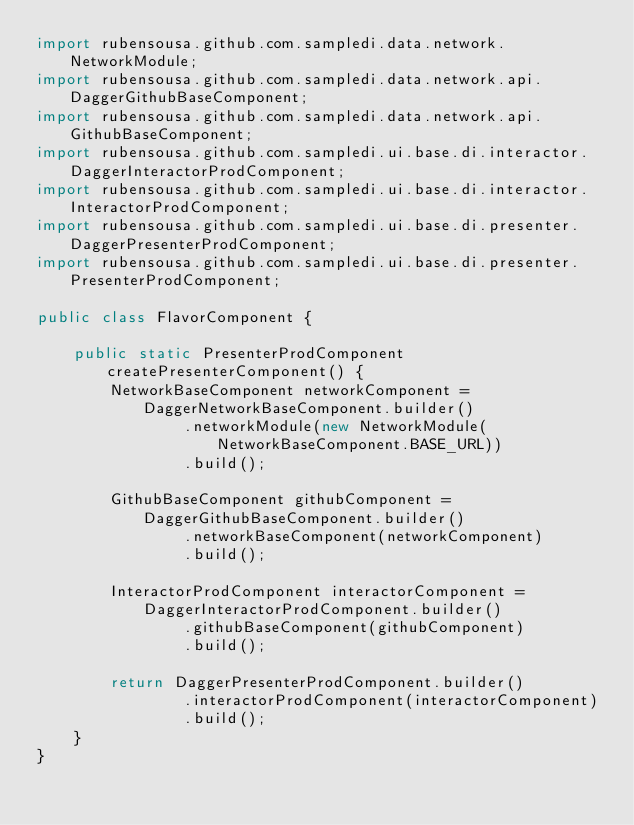<code> <loc_0><loc_0><loc_500><loc_500><_Java_>import rubensousa.github.com.sampledi.data.network.NetworkModule;
import rubensousa.github.com.sampledi.data.network.api.DaggerGithubBaseComponent;
import rubensousa.github.com.sampledi.data.network.api.GithubBaseComponent;
import rubensousa.github.com.sampledi.ui.base.di.interactor.DaggerInteractorProdComponent;
import rubensousa.github.com.sampledi.ui.base.di.interactor.InteractorProdComponent;
import rubensousa.github.com.sampledi.ui.base.di.presenter.DaggerPresenterProdComponent;
import rubensousa.github.com.sampledi.ui.base.di.presenter.PresenterProdComponent;

public class FlavorComponent {

    public static PresenterProdComponent createPresenterComponent() {
        NetworkBaseComponent networkComponent = DaggerNetworkBaseComponent.builder()
                .networkModule(new NetworkModule(NetworkBaseComponent.BASE_URL))
                .build();

        GithubBaseComponent githubComponent = DaggerGithubBaseComponent.builder()
                .networkBaseComponent(networkComponent)
                .build();

        InteractorProdComponent interactorComponent = DaggerInteractorProdComponent.builder()
                .githubBaseComponent(githubComponent)
                .build();

        return DaggerPresenterProdComponent.builder()
                .interactorProdComponent(interactorComponent)
                .build();
    }
}
</code> 